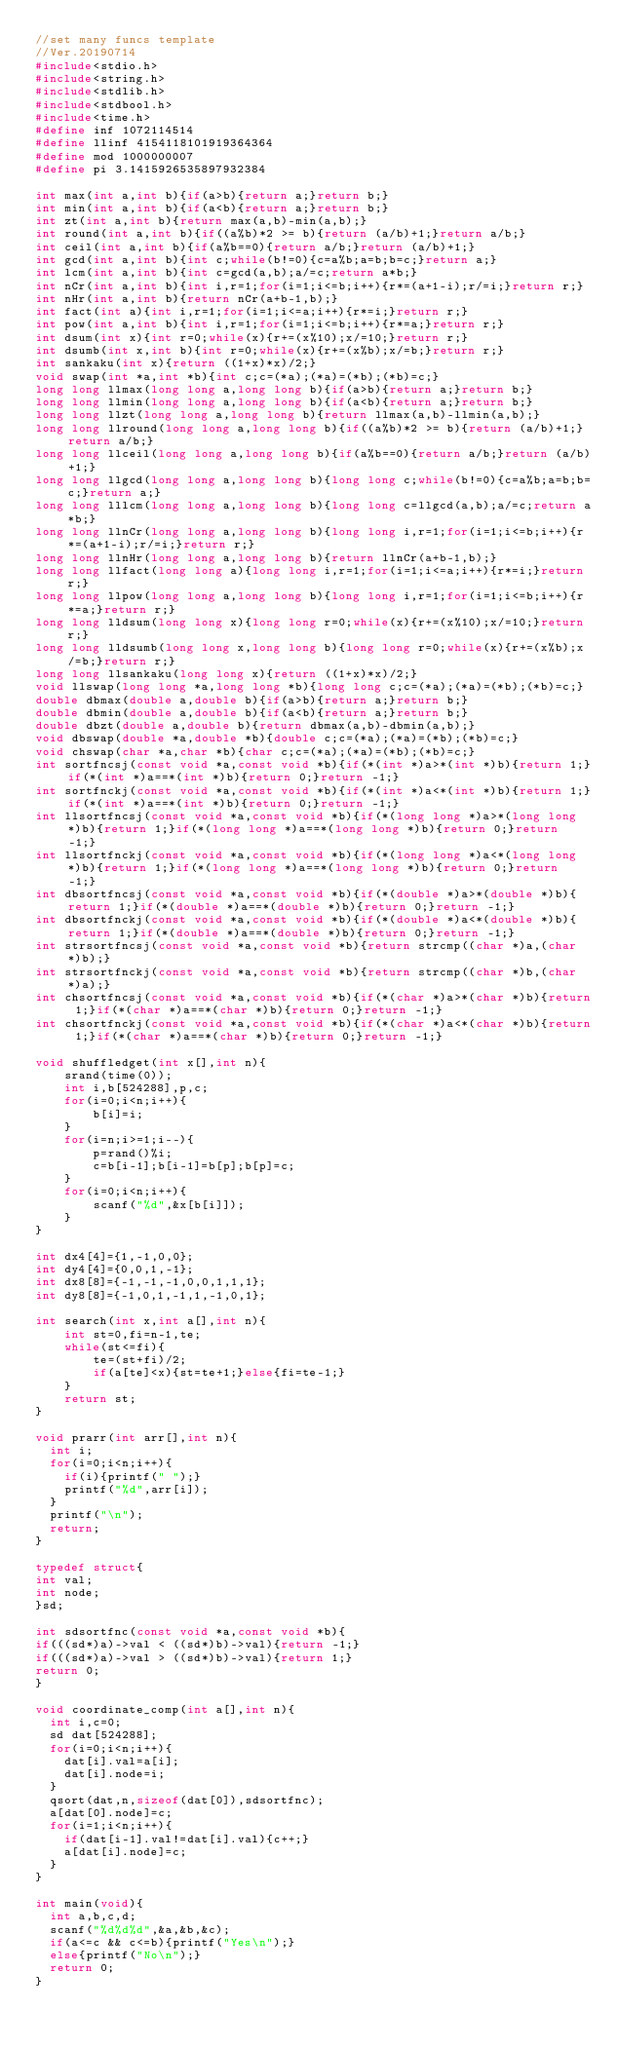Convert code to text. <code><loc_0><loc_0><loc_500><loc_500><_C_>//set many funcs template
//Ver.20190714
#include<stdio.h>
#include<string.h>
#include<stdlib.h>
#include<stdbool.h>
#include<time.h>
#define inf 1072114514
#define llinf 4154118101919364364
#define mod 1000000007
#define pi 3.1415926535897932384

int max(int a,int b){if(a>b){return a;}return b;}
int min(int a,int b){if(a<b){return a;}return b;}
int zt(int a,int b){return max(a,b)-min(a,b);}
int round(int a,int b){if((a%b)*2 >= b){return (a/b)+1;}return a/b;}
int ceil(int a,int b){if(a%b==0){return a/b;}return (a/b)+1;}
int gcd(int a,int b){int c;while(b!=0){c=a%b;a=b;b=c;}return a;}
int lcm(int a,int b){int c=gcd(a,b);a/=c;return a*b;}
int nCr(int a,int b){int i,r=1;for(i=1;i<=b;i++){r*=(a+1-i);r/=i;}return r;}
int nHr(int a,int b){return nCr(a+b-1,b);}
int fact(int a){int i,r=1;for(i=1;i<=a;i++){r*=i;}return r;}
int pow(int a,int b){int i,r=1;for(i=1;i<=b;i++){r*=a;}return r;}
int dsum(int x){int r=0;while(x){r+=(x%10);x/=10;}return r;}
int dsumb(int x,int b){int r=0;while(x){r+=(x%b);x/=b;}return r;}
int sankaku(int x){return ((1+x)*x)/2;}
void swap(int *a,int *b){int c;c=(*a);(*a)=(*b);(*b)=c;}
long long llmax(long long a,long long b){if(a>b){return a;}return b;}
long long llmin(long long a,long long b){if(a<b){return a;}return b;}
long long llzt(long long a,long long b){return llmax(a,b)-llmin(a,b);}
long long llround(long long a,long long b){if((a%b)*2 >= b){return (a/b)+1;}return a/b;}
long long llceil(long long a,long long b){if(a%b==0){return a/b;}return (a/b)+1;}
long long llgcd(long long a,long long b){long long c;while(b!=0){c=a%b;a=b;b=c;}return a;}
long long lllcm(long long a,long long b){long long c=llgcd(a,b);a/=c;return a*b;}
long long llnCr(long long a,long long b){long long i,r=1;for(i=1;i<=b;i++){r*=(a+1-i);r/=i;}return r;}
long long llnHr(long long a,long long b){return llnCr(a+b-1,b);}
long long llfact(long long a){long long i,r=1;for(i=1;i<=a;i++){r*=i;}return r;}
long long llpow(long long a,long long b){long long i,r=1;for(i=1;i<=b;i++){r*=a;}return r;}
long long lldsum(long long x){long long r=0;while(x){r+=(x%10);x/=10;}return r;}
long long lldsumb(long long x,long long b){long long r=0;while(x){r+=(x%b);x/=b;}return r;}
long long llsankaku(long long x){return ((1+x)*x)/2;}
void llswap(long long *a,long long *b){long long c;c=(*a);(*a)=(*b);(*b)=c;}
double dbmax(double a,double b){if(a>b){return a;}return b;}
double dbmin(double a,double b){if(a<b){return a;}return b;}
double dbzt(double a,double b){return dbmax(a,b)-dbmin(a,b);}
void dbswap(double *a,double *b){double c;c=(*a);(*a)=(*b);(*b)=c;}
void chswap(char *a,char *b){char c;c=(*a);(*a)=(*b);(*b)=c;}
int sortfncsj(const void *a,const void *b){if(*(int *)a>*(int *)b){return 1;}if(*(int *)a==*(int *)b){return 0;}return -1;}
int sortfnckj(const void *a,const void *b){if(*(int *)a<*(int *)b){return 1;}if(*(int *)a==*(int *)b){return 0;}return -1;}
int llsortfncsj(const void *a,const void *b){if(*(long long *)a>*(long long *)b){return 1;}if(*(long long *)a==*(long long *)b){return 0;}return -1;}
int llsortfnckj(const void *a,const void *b){if(*(long long *)a<*(long long *)b){return 1;}if(*(long long *)a==*(long long *)b){return 0;}return -1;}
int dbsortfncsj(const void *a,const void *b){if(*(double *)a>*(double *)b){return 1;}if(*(double *)a==*(double *)b){return 0;}return -1;}
int dbsortfnckj(const void *a,const void *b){if(*(double *)a<*(double *)b){return 1;}if(*(double *)a==*(double *)b){return 0;}return -1;}
int strsortfncsj(const void *a,const void *b){return strcmp((char *)a,(char *)b);}
int strsortfnckj(const void *a,const void *b){return strcmp((char *)b,(char *)a);}
int chsortfncsj(const void *a,const void *b){if(*(char *)a>*(char *)b){return 1;}if(*(char *)a==*(char *)b){return 0;}return -1;}
int chsortfnckj(const void *a,const void *b){if(*(char *)a<*(char *)b){return 1;}if(*(char *)a==*(char *)b){return 0;}return -1;}

void shuffledget(int x[],int n){
    srand(time(0));
    int i,b[524288],p,c;
    for(i=0;i<n;i++){
        b[i]=i;
    }
    for(i=n;i>=1;i--){
        p=rand()%i;
        c=b[i-1];b[i-1]=b[p];b[p]=c;
    }
    for(i=0;i<n;i++){
        scanf("%d",&x[b[i]]);
    }
}

int dx4[4]={1,-1,0,0};
int dy4[4]={0,0,1,-1};
int dx8[8]={-1,-1,-1,0,0,1,1,1};
int dy8[8]={-1,0,1,-1,1,-1,0,1};

int search(int x,int a[],int n){
    int st=0,fi=n-1,te;
    while(st<=fi){
        te=(st+fi)/2;
        if(a[te]<x){st=te+1;}else{fi=te-1;}
    }
    return st;
}

void prarr(int arr[],int n){
  int i;
  for(i=0;i<n;i++){
    if(i){printf(" ");}
    printf("%d",arr[i]);
  }
  printf("\n");
  return;
}

typedef struct{
int val;
int node;
}sd;

int sdsortfnc(const void *a,const void *b){
if(((sd*)a)->val < ((sd*)b)->val){return -1;}
if(((sd*)a)->val > ((sd*)b)->val){return 1;}
return 0;
}

void coordinate_comp(int a[],int n){
  int i,c=0;
  sd dat[524288];
  for(i=0;i<n;i++){
    dat[i].val=a[i];
    dat[i].node=i;
  }
  qsort(dat,n,sizeof(dat[0]),sdsortfnc);
  a[dat[0].node]=c;
  for(i=1;i<n;i++){
    if(dat[i-1].val!=dat[i].val){c++;}
    a[dat[i].node]=c;
  }
}

int main(void){
  int a,b,c,d;
  scanf("%d%d%d",&a,&b,&c);
  if(a<=c && c<=b){printf("Yes\n");}
  else{printf("No\n");}
  return 0;
}
</code> 